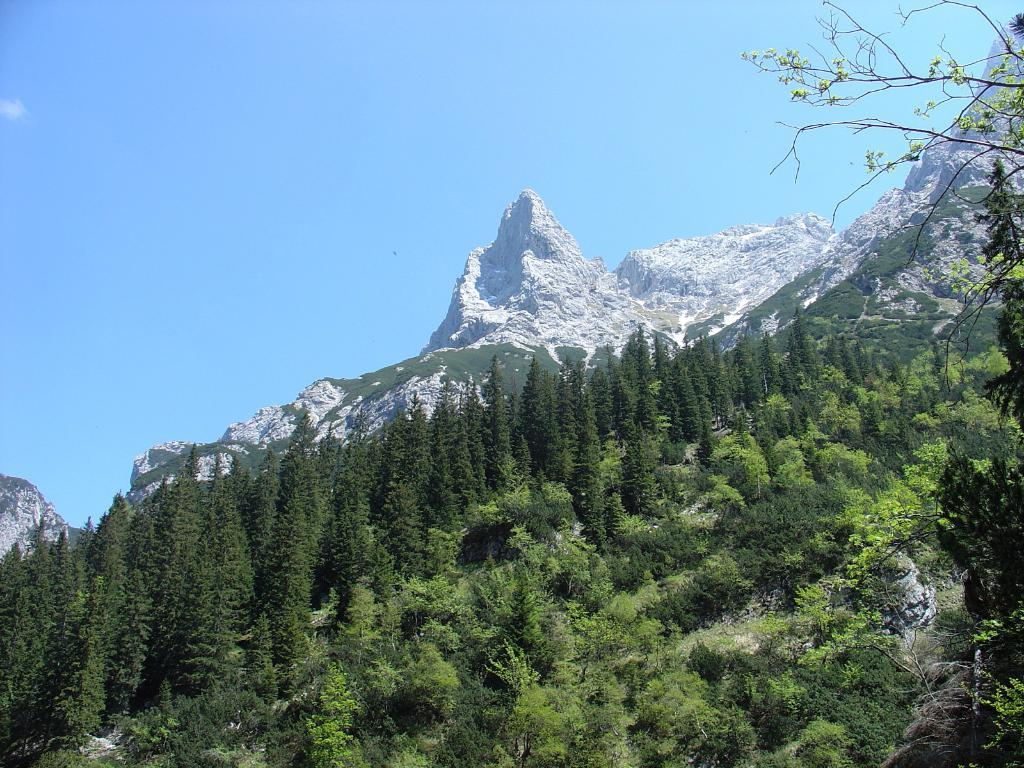What type of vegetation can be seen in the image? There are trees in the image. What geographical feature is present in the image? There is a mountain in the image. What part of the natural environment is visible in the image? The sky is visible in the background of the image. What type of breakfast is being served in the image? There is no breakfast present in the image; it features trees, a mountain, and the sky. What activity is taking place in the image? The image does not depict any specific activity; it shows natural elements such as trees, a mountain, and the sky. 